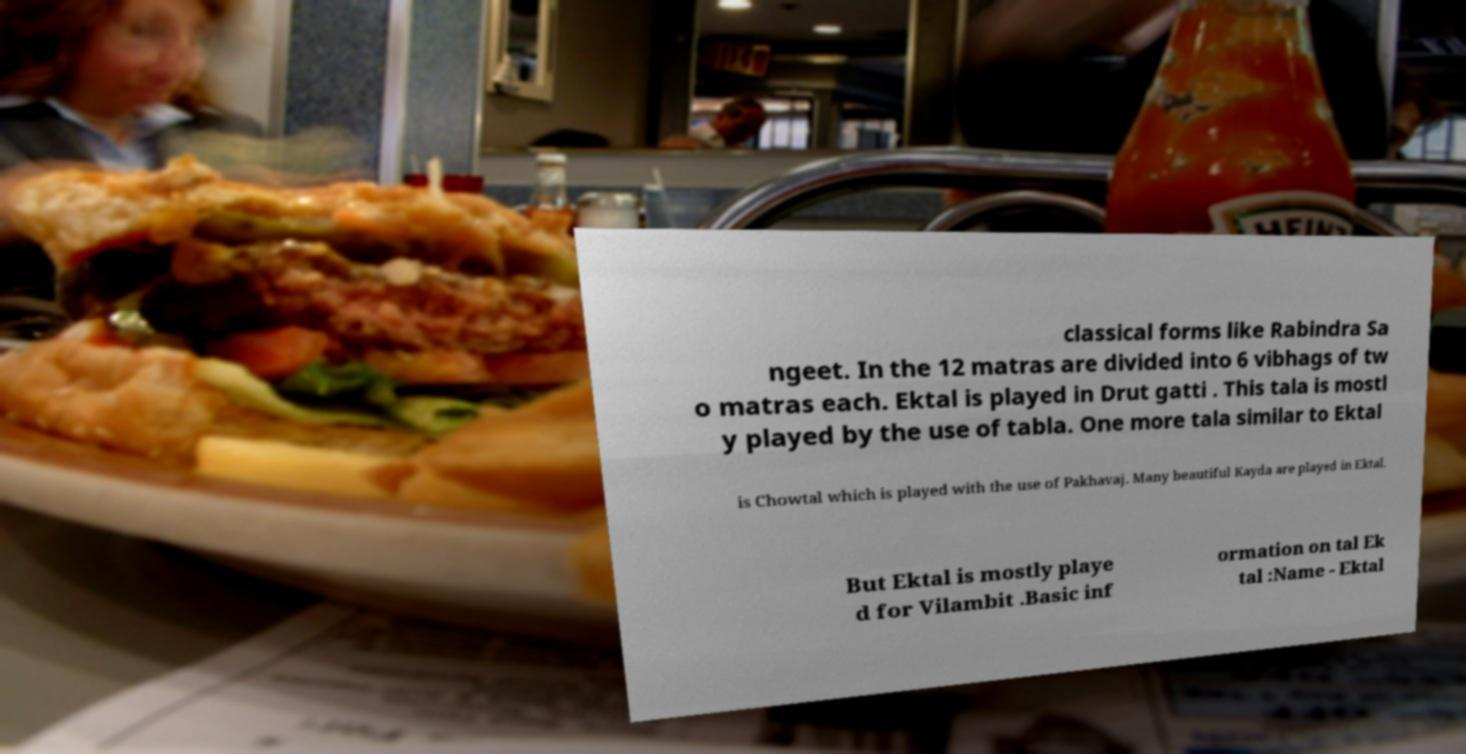Please read and relay the text visible in this image. What does it say? classical forms like Rabindra Sa ngeet. In the 12 matras are divided into 6 vibhags of tw o matras each. Ektal is played in Drut gatti . This tala is mostl y played by the use of tabla. One more tala similar to Ektal is Chowtal which is played with the use of Pakhavaj. Many beautiful Kayda are played in Ektal. But Ektal is mostly playe d for Vilambit .Basic inf ormation on tal Ek tal :Name - Ektal 